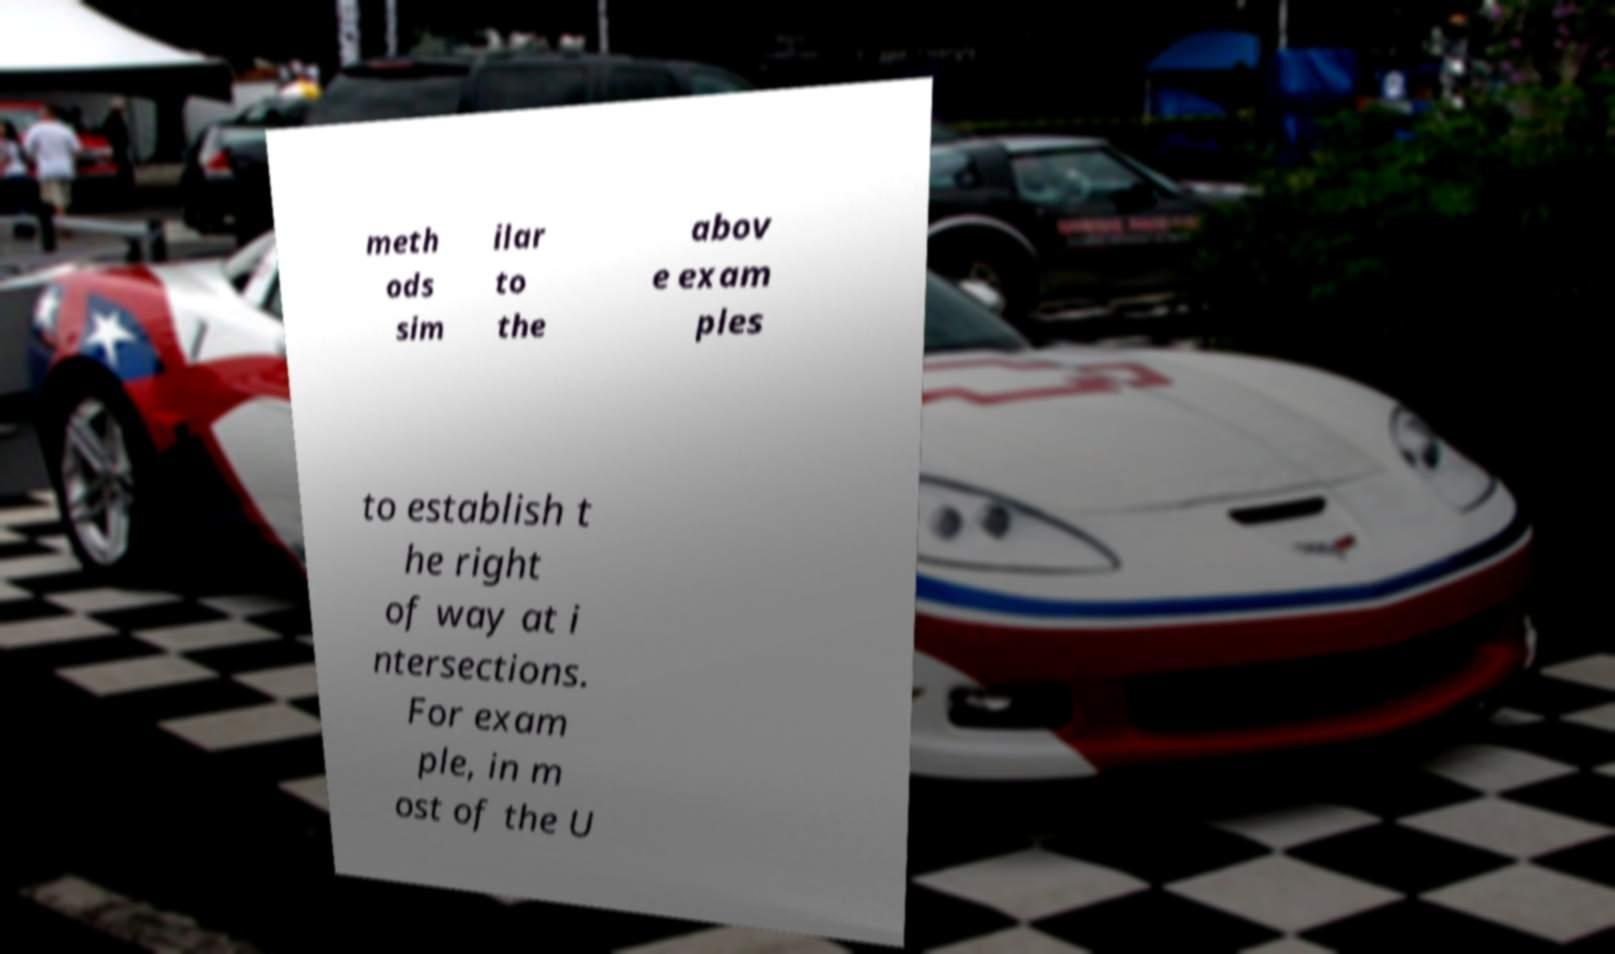Could you extract and type out the text from this image? meth ods sim ilar to the abov e exam ples to establish t he right of way at i ntersections. For exam ple, in m ost of the U 